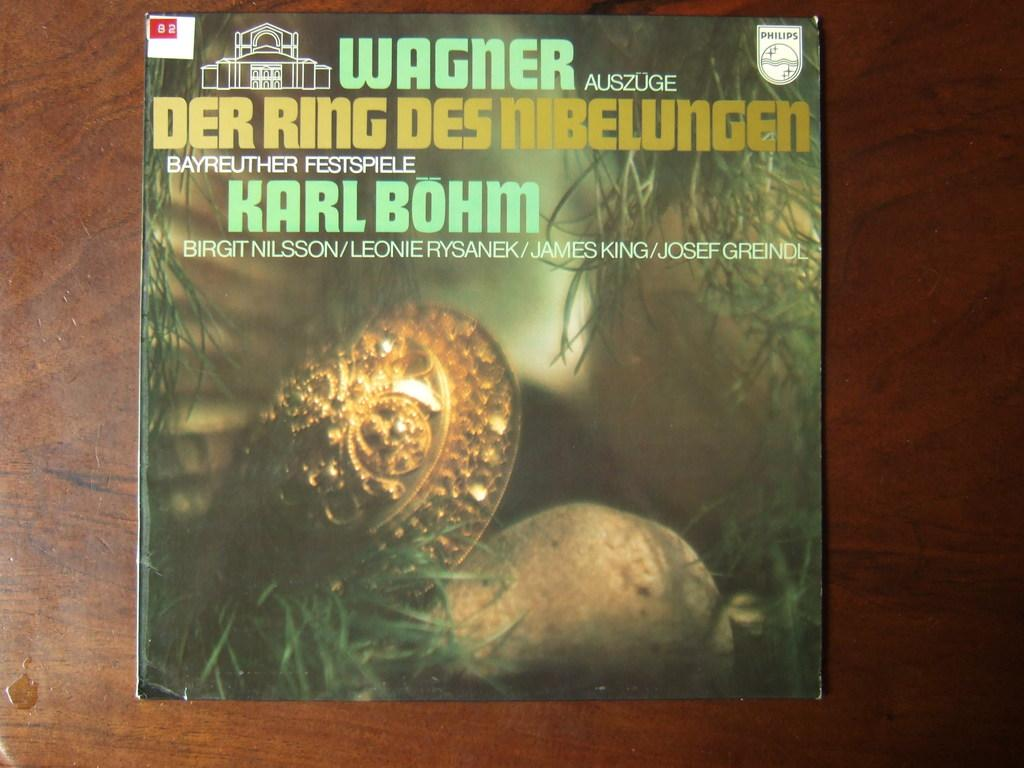<image>
Give a short and clear explanation of the subsequent image. A book that has a German title labeled Der Ring Des Nibelungen 